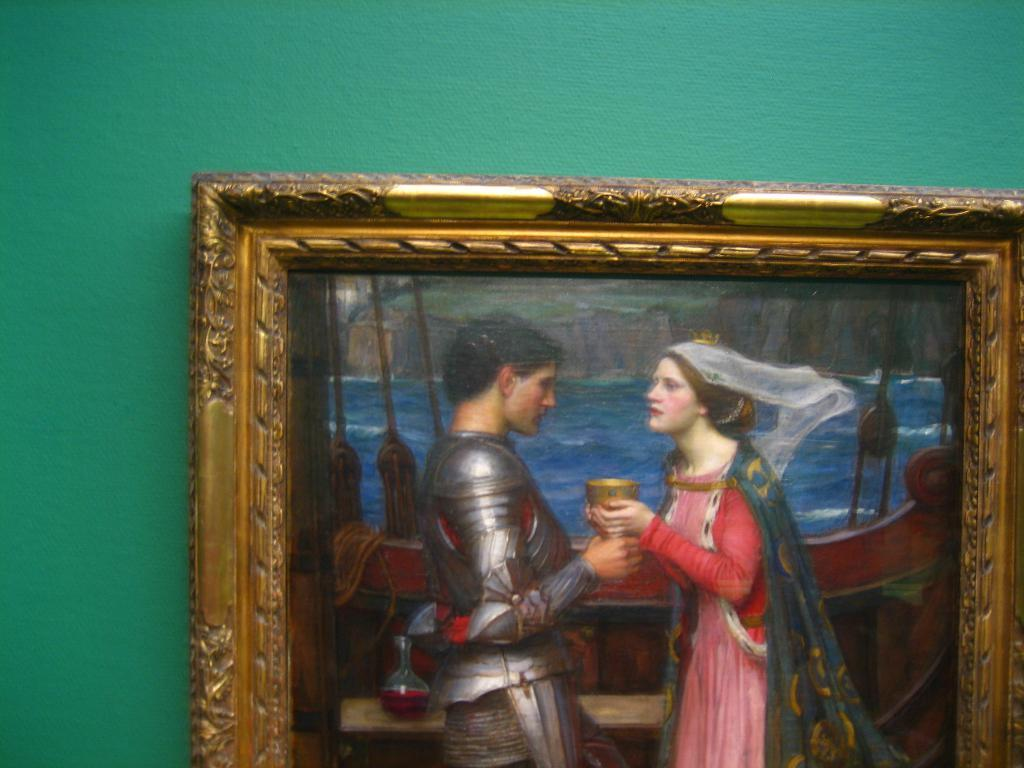What is on the green wall in the image? There is a frame on the green wall. What can be seen inside the frame? There are people in the frame. What object is on the table in the image? There is a glass object on the table. Can you describe the presence of water in the image? There is water visible in the image. How many members are on the team in the image? There is no team present in the image; it features a frame with people inside. What type of river can be seen flowing in the image? There is no river present in the image; it features a frame with people inside and a glass object on a table. 